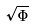Convert formula to latex. <formula><loc_0><loc_0><loc_500><loc_500>\sqrt { \Phi }</formula> 